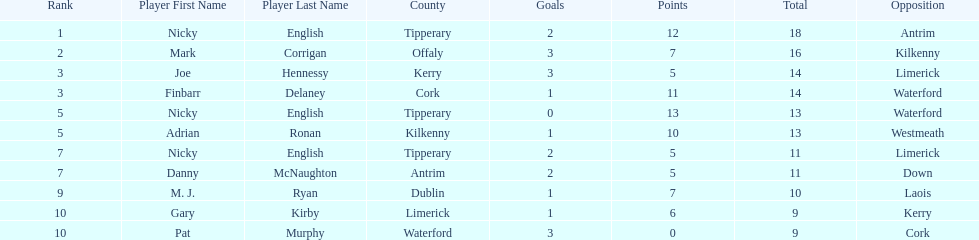Who was the top ranked player in a single game? Nicky English. 